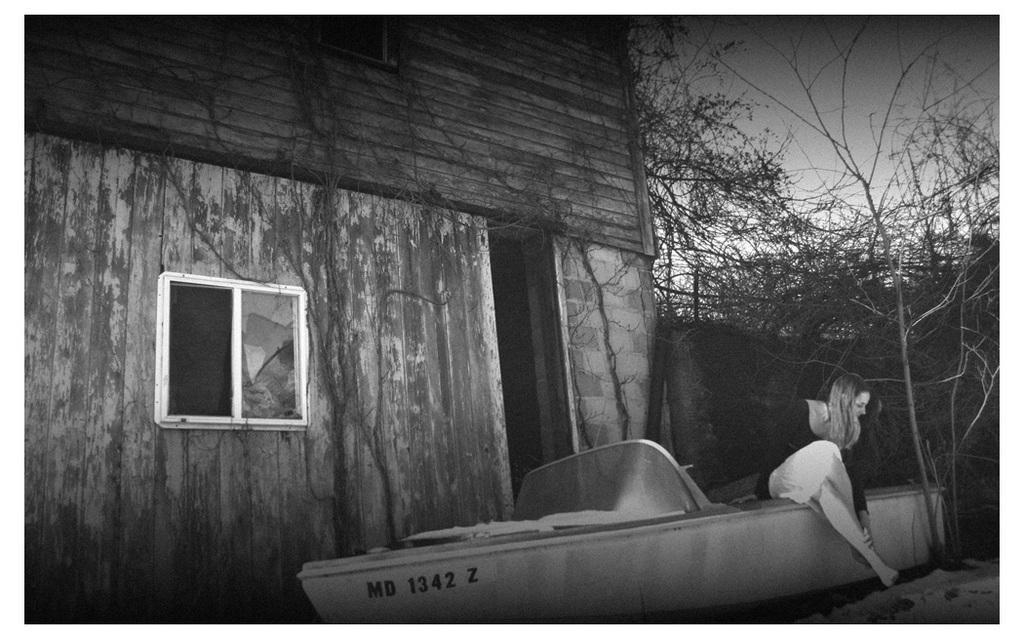Could you give a brief overview of what you see in this image? This is a black and white image. In this image, in the middle, we can see a woman sitting on the boat. On the right side, we can see some trees. On the left side, we can see a building, glass window. At the top, we can see a sky. 